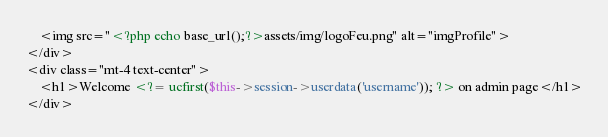<code> <loc_0><loc_0><loc_500><loc_500><_PHP_>	<img src="<?php echo base_url();?>assets/img/logoFeu.png" alt="imgProfile">
</div>
<div class="mt-4 text-center">
	<h1>Welcome <?= ucfirst($this->session->userdata('username')); ?> on admin page</h1>
</div>
</code> 